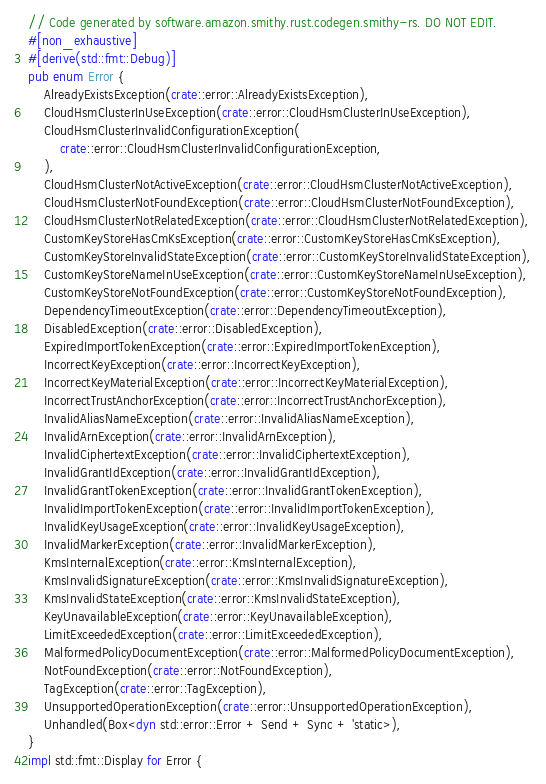Convert code to text. <code><loc_0><loc_0><loc_500><loc_500><_Rust_>// Code generated by software.amazon.smithy.rust.codegen.smithy-rs. DO NOT EDIT.
#[non_exhaustive]
#[derive(std::fmt::Debug)]
pub enum Error {
    AlreadyExistsException(crate::error::AlreadyExistsException),
    CloudHsmClusterInUseException(crate::error::CloudHsmClusterInUseException),
    CloudHsmClusterInvalidConfigurationException(
        crate::error::CloudHsmClusterInvalidConfigurationException,
    ),
    CloudHsmClusterNotActiveException(crate::error::CloudHsmClusterNotActiveException),
    CloudHsmClusterNotFoundException(crate::error::CloudHsmClusterNotFoundException),
    CloudHsmClusterNotRelatedException(crate::error::CloudHsmClusterNotRelatedException),
    CustomKeyStoreHasCmKsException(crate::error::CustomKeyStoreHasCmKsException),
    CustomKeyStoreInvalidStateException(crate::error::CustomKeyStoreInvalidStateException),
    CustomKeyStoreNameInUseException(crate::error::CustomKeyStoreNameInUseException),
    CustomKeyStoreNotFoundException(crate::error::CustomKeyStoreNotFoundException),
    DependencyTimeoutException(crate::error::DependencyTimeoutException),
    DisabledException(crate::error::DisabledException),
    ExpiredImportTokenException(crate::error::ExpiredImportTokenException),
    IncorrectKeyException(crate::error::IncorrectKeyException),
    IncorrectKeyMaterialException(crate::error::IncorrectKeyMaterialException),
    IncorrectTrustAnchorException(crate::error::IncorrectTrustAnchorException),
    InvalidAliasNameException(crate::error::InvalidAliasNameException),
    InvalidArnException(crate::error::InvalidArnException),
    InvalidCiphertextException(crate::error::InvalidCiphertextException),
    InvalidGrantIdException(crate::error::InvalidGrantIdException),
    InvalidGrantTokenException(crate::error::InvalidGrantTokenException),
    InvalidImportTokenException(crate::error::InvalidImportTokenException),
    InvalidKeyUsageException(crate::error::InvalidKeyUsageException),
    InvalidMarkerException(crate::error::InvalidMarkerException),
    KmsInternalException(crate::error::KmsInternalException),
    KmsInvalidSignatureException(crate::error::KmsInvalidSignatureException),
    KmsInvalidStateException(crate::error::KmsInvalidStateException),
    KeyUnavailableException(crate::error::KeyUnavailableException),
    LimitExceededException(crate::error::LimitExceededException),
    MalformedPolicyDocumentException(crate::error::MalformedPolicyDocumentException),
    NotFoundException(crate::error::NotFoundException),
    TagException(crate::error::TagException),
    UnsupportedOperationException(crate::error::UnsupportedOperationException),
    Unhandled(Box<dyn std::error::Error + Send + Sync + 'static>),
}
impl std::fmt::Display for Error {</code> 